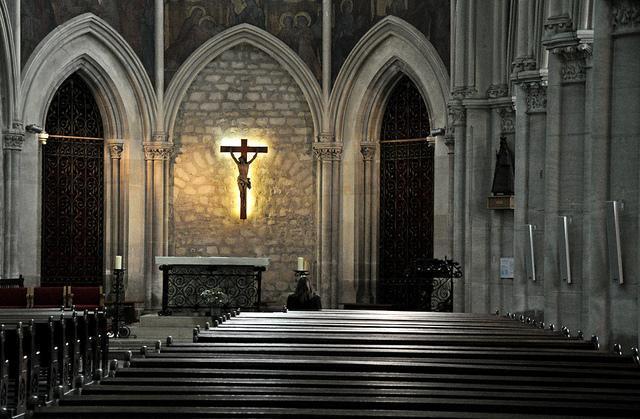What is she doing?
Indicate the correct response by choosing from the four available options to answer the question.
Options: Resting, praying, hiding, eating. Praying. How might you be considered if you set a fire here?
Select the accurate answer and provide justification: `Answer: choice
Rationale: srationale.`
Options: Sacrilegious, forest-fire starter, chef, camper. Answer: sacrilegious.
Rationale: It is violating a sacred thing. 